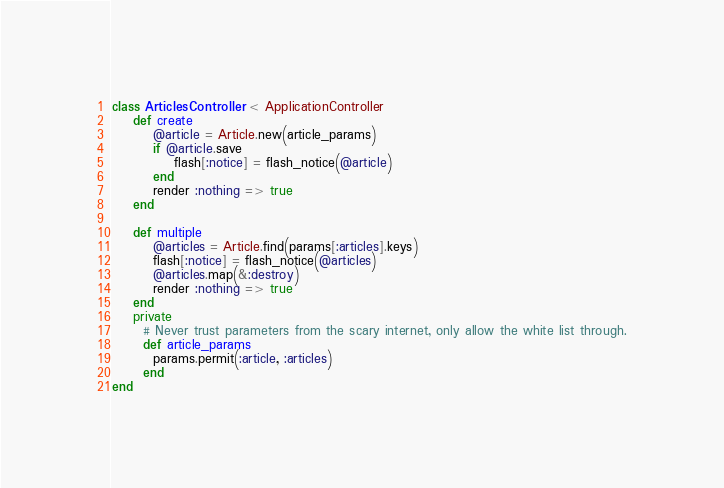Convert code to text. <code><loc_0><loc_0><loc_500><loc_500><_Ruby_>class ArticlesController < ApplicationController
	def create
		@article = Article.new(article_params)
		if @article.save
			flash[:notice] = flash_notice(@article)
		end
		render :nothing => true
	end

	def multiple
		@articles = Article.find(params[:articles].keys)
		flash[:notice] = flash_notice(@articles)
		@articles.map(&:destroy)
		render :nothing => true
	end
    private
      # Never trust parameters from the scary internet, only allow the white list through.
      def article_params
        params.permit(:article, :articles)
      end
end
</code> 